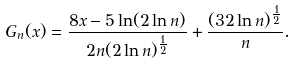Convert formula to latex. <formula><loc_0><loc_0><loc_500><loc_500>G _ { n } ( x ) = \frac { 8 x - 5 \ln ( 2 \ln n ) } { 2 n ( 2 \ln n ) ^ { \frac { 1 } { 2 } } } + \frac { ( 3 2 \ln n ) ^ { \frac { 1 } { 2 } } } { n } .</formula> 